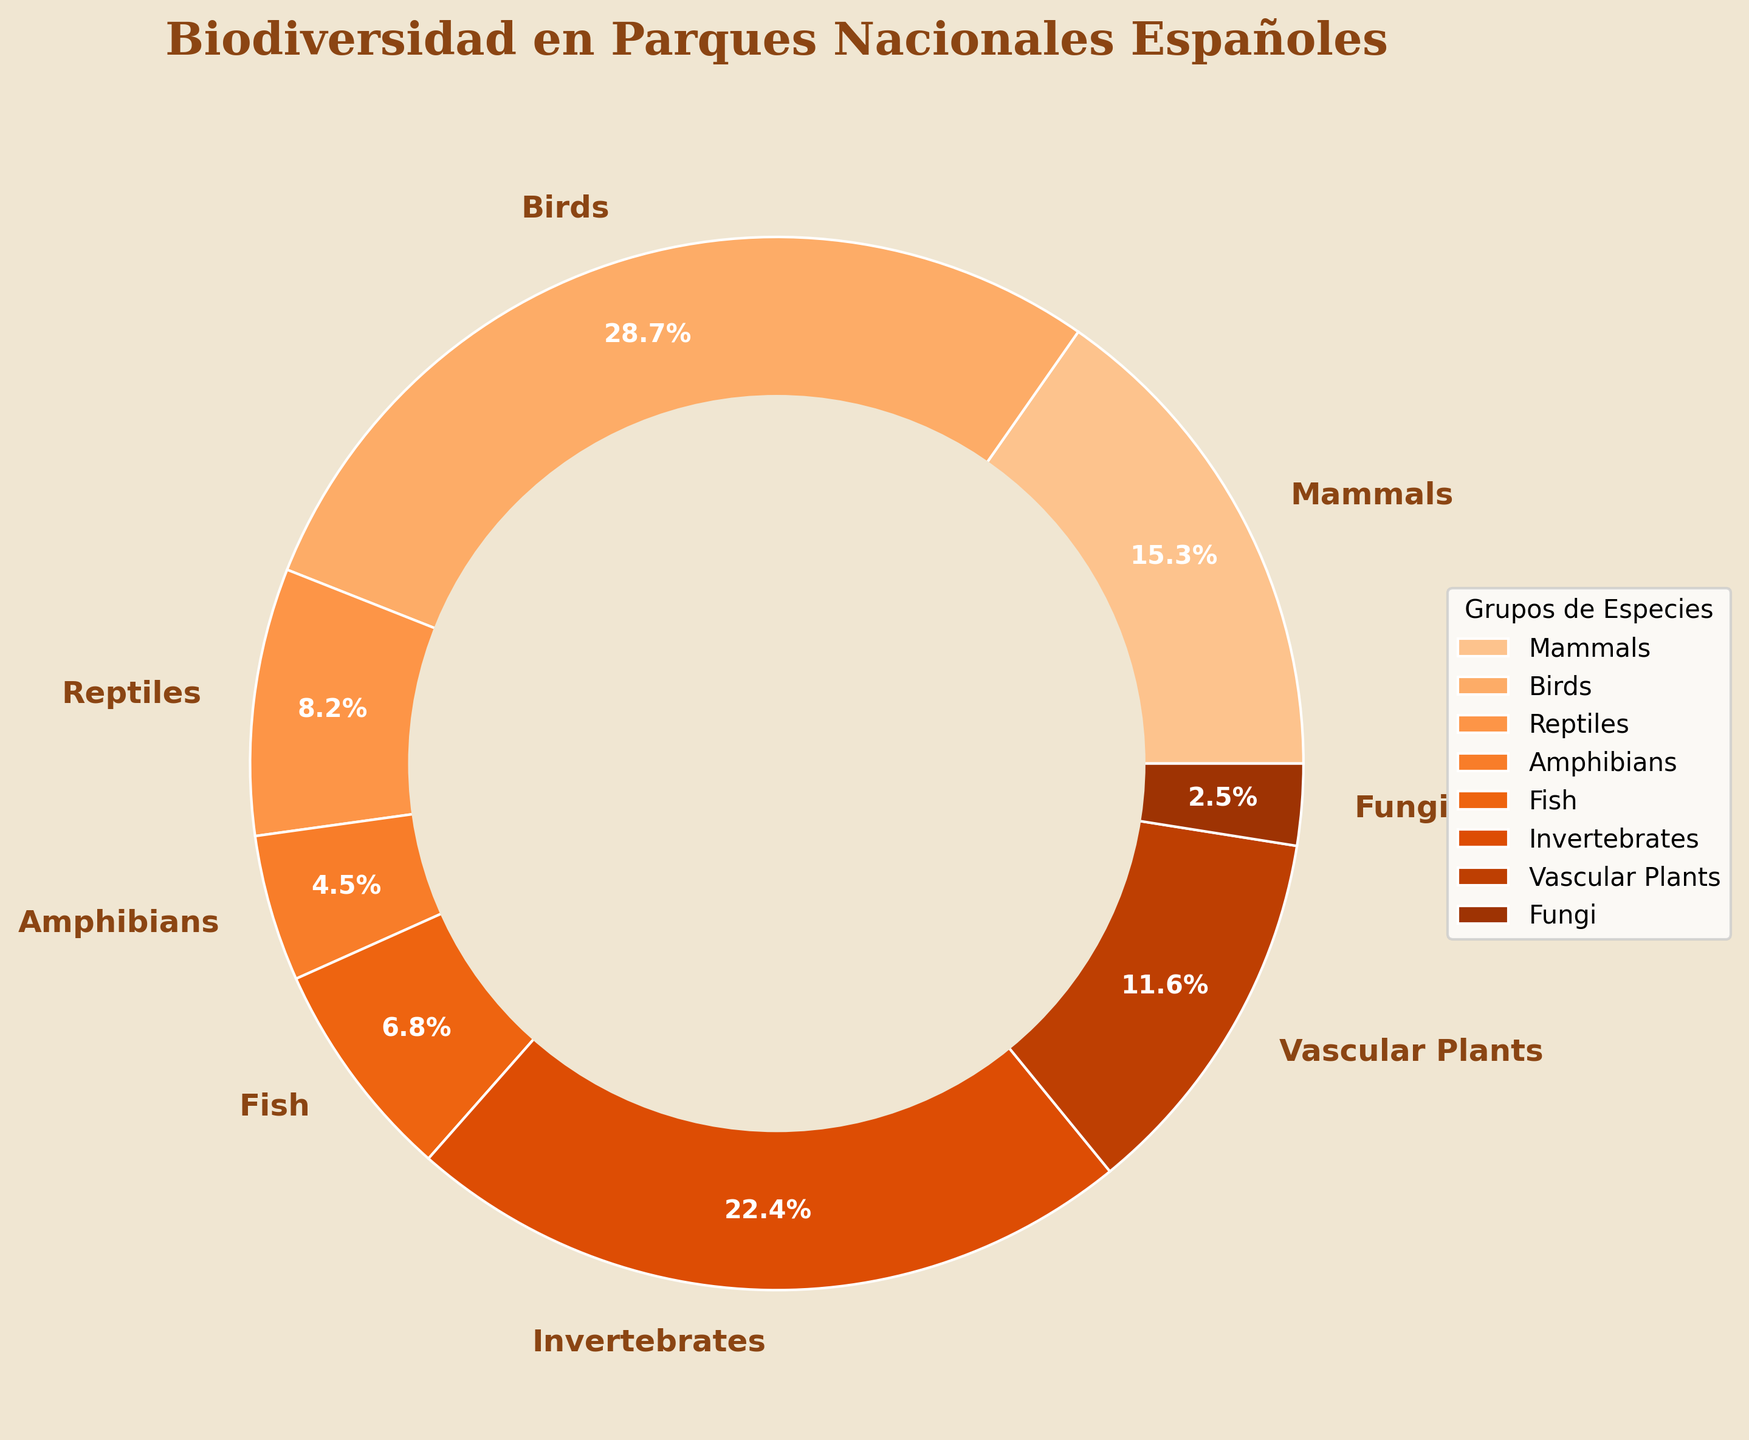Which species group has the highest percentage? To determine the species group with the highest percentage, visually inspect the pie chart and identify the largest wedge. The label "Birds" shows 28.7%, which is the highest percentage.
Answer: Birds Which species group has the lowest representation? Find the smallest wedge on the pie chart and check its label. The smallest wedge is labeled "Fungi" with 2.5%.
Answer: Fungi What is the combined percentage of Birds and Mammals? Locate the percentages for Birds (28.7%) and Mammals (15.3%) on the chart, then add these percentages together: 28.7% + 15.3% = 44%.
Answer: 44% How does the percentage of Invertebrates compare to Vascular Plants? Check the pie chart for the percentages of Invertebrates (22.4%) and Vascular Plants (11.6%), then compare these values. Invertebrates have a higher percentage (22.4%) compared to Vascular Plants (11.6%).
Answer: Invertebrates have a higher percentage What is the difference between the percentages of Birds and Fish? Look at the pie chart to find the percentages for Birds (28.7%) and Fish (6.8%). Subtract the percentage of Fish from Birds: 28.7% - 6.8% = 21.9%.
Answer: 21.9% What is the average percentage of Reptiles, Amphibians, and Fish? Identify the percentages for Reptiles (8.2%), Amphibians (4.5%), and Fish (6.8%) from the chart. Add these percentages and divide by 3: (8.2% + 4.5% + 6.8%) / 3 = 6.5%.
Answer: 6.5% Compare the combined percentage of Mammals and Amphibians to that of Reptiles and Fish. Which is larger? Combine the percentages for each pair: Mammals (15.3%) + Amphibians (4.5%) = 19.8%, and Reptiles (8.2%) + Fish (6.8%) = 15%. Since 19.8% is greater than 15%, the combined percentage of Mammals and Amphibians is larger.
Answer: Mammals and Amphibians combined What proportion of total biodiversity do Vascular Plants and Fungi represent together? Add the percentages of Vascular Plants (11.6%) and Fungi (2.5%) from the chart to find their combined proportion: 11.6% + 2.5% = 14.1%.
Answer: 14.1% Is the percentage of Invertebrates greater than the sum of Reptiles and Amphibians? First, sum the percentages of Reptiles (8.2%) and Amphibians (4.5%): 8.2% + 4.5% = 12.7%. Since Invertebrates are 22.4%, which is greater than 12.7%, the percentage of Invertebrates is indeed greater.
Answer: Yes, Invertebrates are greater What is the combined percentage of all animal groups (Mammals, Birds, Reptiles, Amphibians, Fish, Invertebrates)? Add the percentages of all mentioned animal groups: Mammals (15.3%) + Birds (28.7%) + Reptiles (8.2%) + Amphibians (4.5%) + Fish (6.8%) + Invertebrates (22.4%) = 85.9%.
Answer: 85.9% 